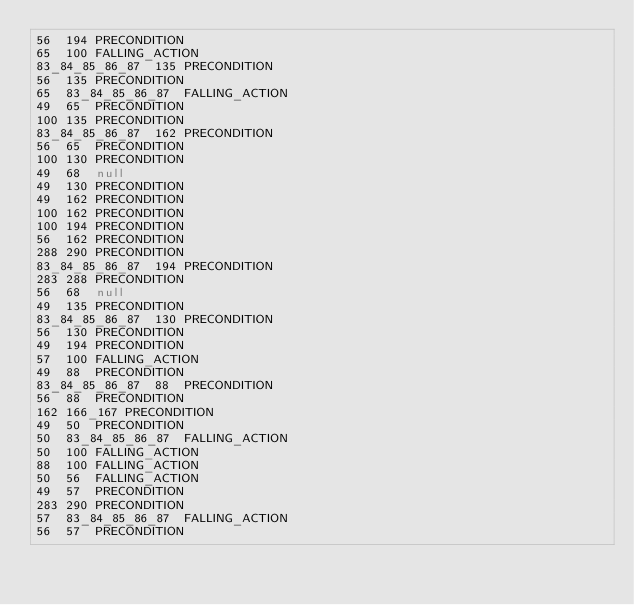<code> <loc_0><loc_0><loc_500><loc_500><_SQL_>56	194	PRECONDITION
65	100	FALLING_ACTION
83_84_85_86_87	135	PRECONDITION
56	135	PRECONDITION
65	83_84_85_86_87	FALLING_ACTION
49	65	PRECONDITION
100	135	PRECONDITION
83_84_85_86_87	162	PRECONDITION
56	65	PRECONDITION
100	130	PRECONDITION
49	68	null
49	130	PRECONDITION
49	162	PRECONDITION
100	162	PRECONDITION
100	194	PRECONDITION
56	162	PRECONDITION
288	290	PRECONDITION
83_84_85_86_87	194	PRECONDITION
283	288	PRECONDITION
56	68	null
49	135	PRECONDITION
83_84_85_86_87	130	PRECONDITION
56	130	PRECONDITION
49	194	PRECONDITION
57	100	FALLING_ACTION
49	88	PRECONDITION
83_84_85_86_87	88	PRECONDITION
56	88	PRECONDITION
162	166_167	PRECONDITION
49	50	PRECONDITION
50	83_84_85_86_87	FALLING_ACTION
50	100	FALLING_ACTION
88	100	FALLING_ACTION
50	56	FALLING_ACTION
49	57	PRECONDITION
283	290	PRECONDITION
57	83_84_85_86_87	FALLING_ACTION
56	57	PRECONDITION
</code> 